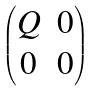<formula> <loc_0><loc_0><loc_500><loc_500>\begin{pmatrix} Q & 0 \\ 0 & 0 \end{pmatrix}</formula> 